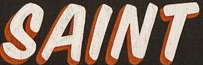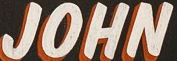What text appears in these images from left to right, separated by a semicolon? SAINT; JOHN 